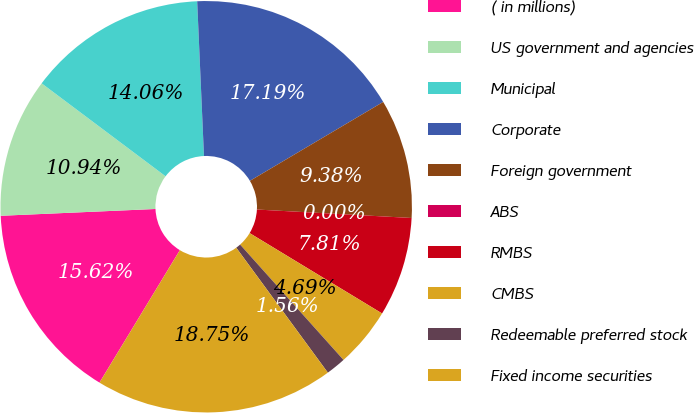<chart> <loc_0><loc_0><loc_500><loc_500><pie_chart><fcel>( in millions)<fcel>US government and agencies<fcel>Municipal<fcel>Corporate<fcel>Foreign government<fcel>ABS<fcel>RMBS<fcel>CMBS<fcel>Redeemable preferred stock<fcel>Fixed income securities<nl><fcel>15.62%<fcel>10.94%<fcel>14.06%<fcel>17.19%<fcel>9.38%<fcel>0.0%<fcel>7.81%<fcel>4.69%<fcel>1.56%<fcel>18.75%<nl></chart> 